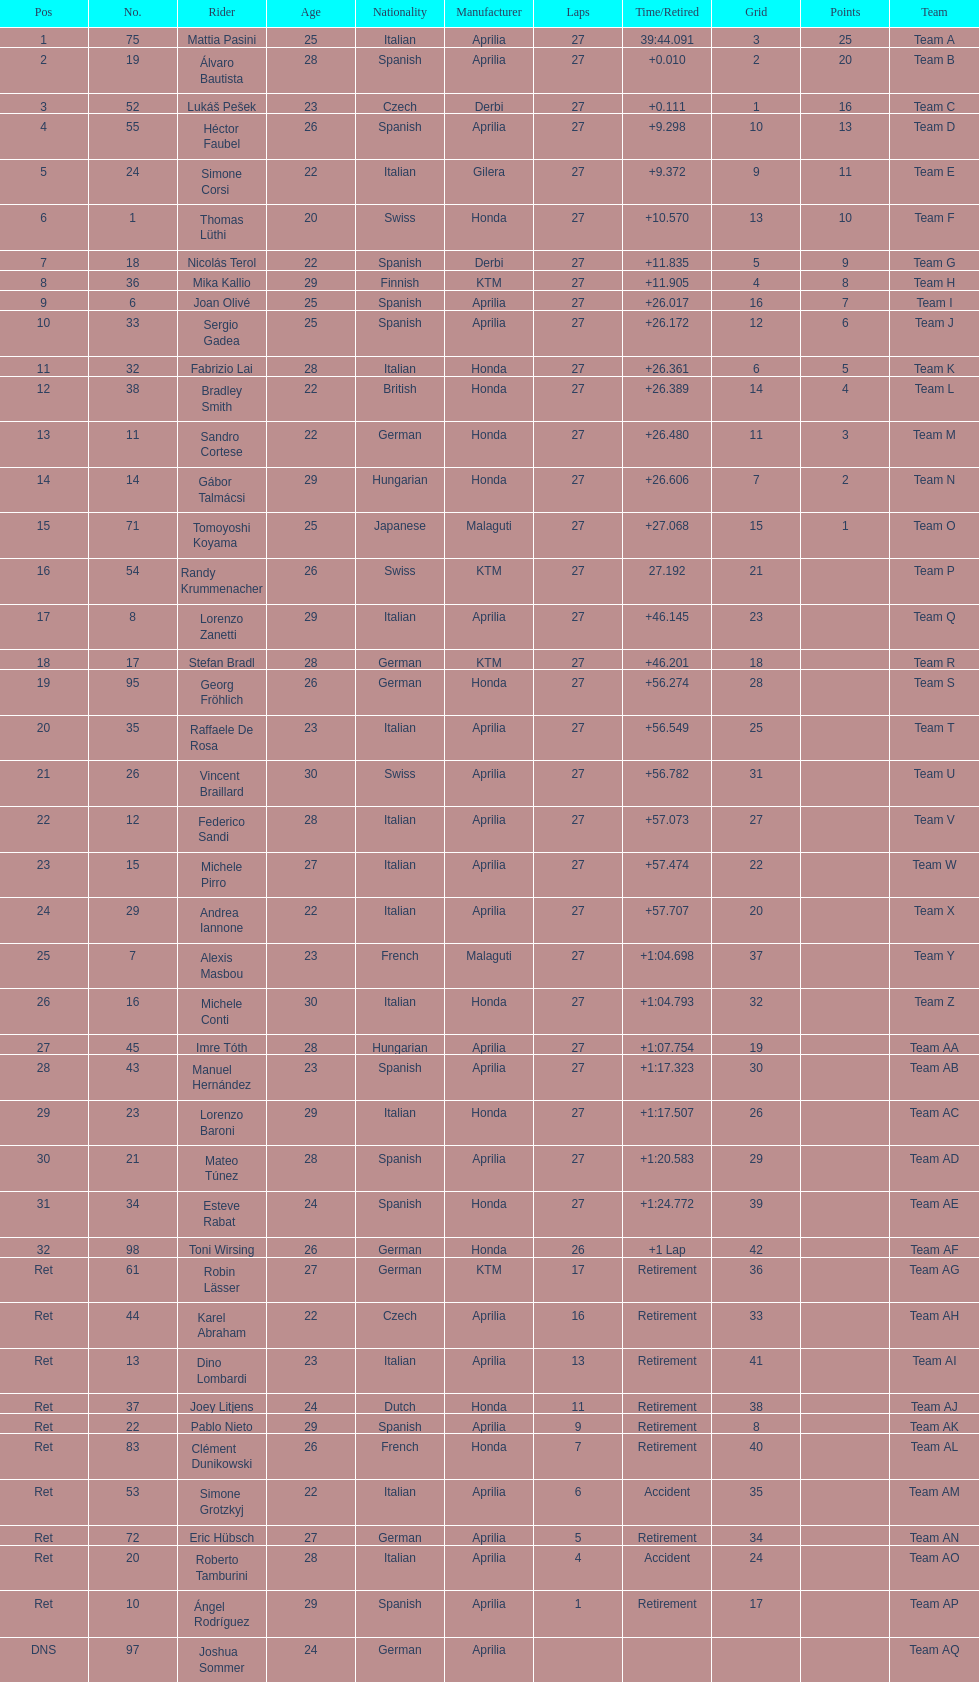Which rider came in first with 25 points? Mattia Pasini. 